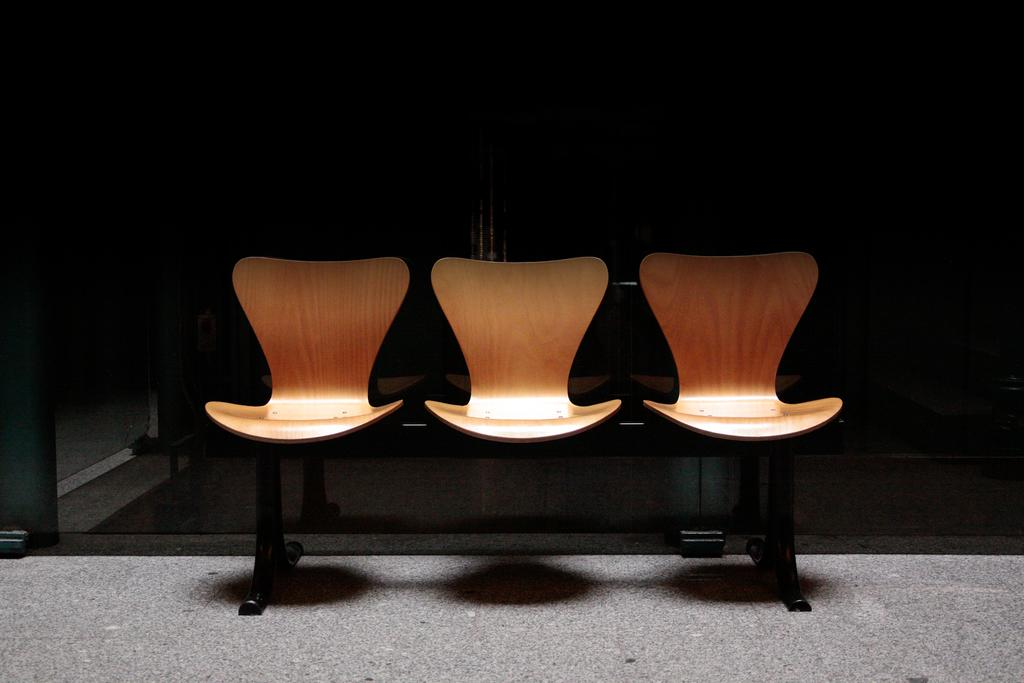How many chairs are visible in the image? There are three chairs in the image. What material are the chairs made of? The chairs are made of wood. Where are the chairs located in the image? The chairs are on the floor. What can be observed about the background of the image? The background appears to be dark. What type of humor is being displayed by the chairs in the image? There is no humor displayed by the chairs in the image; they are simply chairs made of wood and located on the floor. 